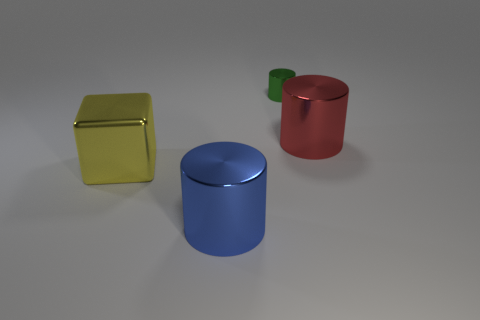Add 4 tiny cyan metallic cylinders. How many objects exist? 8 Subtract all cylinders. How many objects are left? 1 Add 3 big blue cylinders. How many big blue cylinders are left? 4 Add 1 big metallic cylinders. How many big metallic cylinders exist? 3 Subtract 0 brown cylinders. How many objects are left? 4 Subtract all tiny blue shiny cubes. Subtract all yellow shiny blocks. How many objects are left? 3 